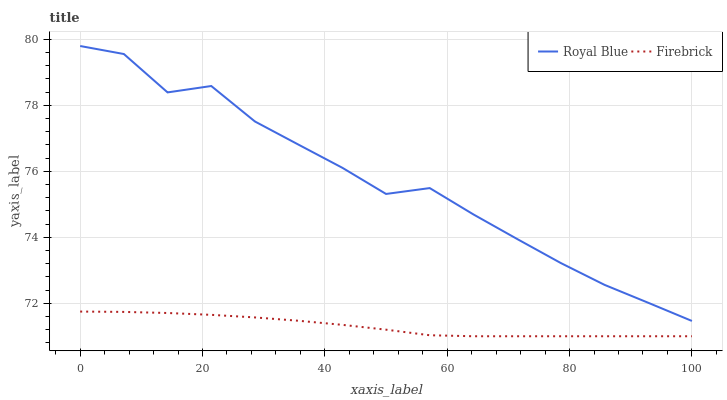Does Firebrick have the maximum area under the curve?
Answer yes or no. No. Is Firebrick the roughest?
Answer yes or no. No. Does Firebrick have the highest value?
Answer yes or no. No. Is Firebrick less than Royal Blue?
Answer yes or no. Yes. Is Royal Blue greater than Firebrick?
Answer yes or no. Yes. Does Firebrick intersect Royal Blue?
Answer yes or no. No. 